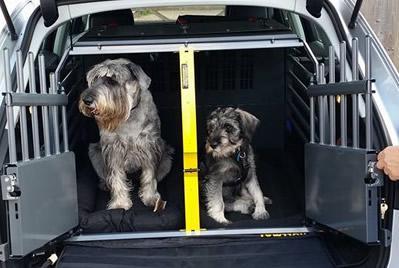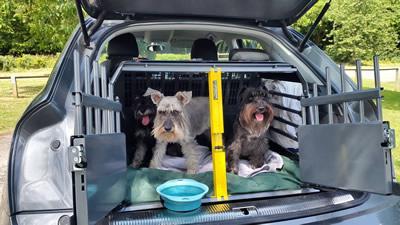The first image is the image on the left, the second image is the image on the right. Evaluate the accuracy of this statement regarding the images: "there is no more then four dogs". Is it true? Answer yes or no. No. The first image is the image on the left, the second image is the image on the right. For the images shown, is this caption "There is a black dog in both images." true? Answer yes or no. No. 